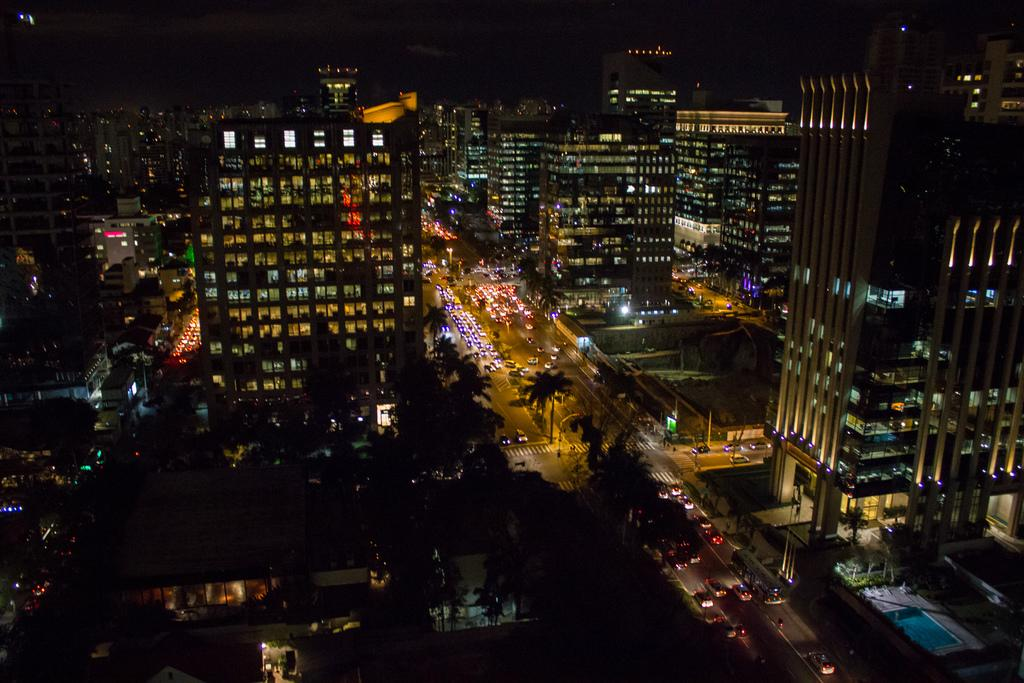What type of view is shown in the image? The image is a top view of a city. What can be seen on the roads in the image? There are vehicles on the road. What type of vegetation is present beside the road? There are trees beside the road. What structures are visible in the image? There are buildings in the image. What color of paint is used on the giraffe in the image? There is no giraffe present in the image; it is a top view of a city with vehicles, trees, and buildings. 